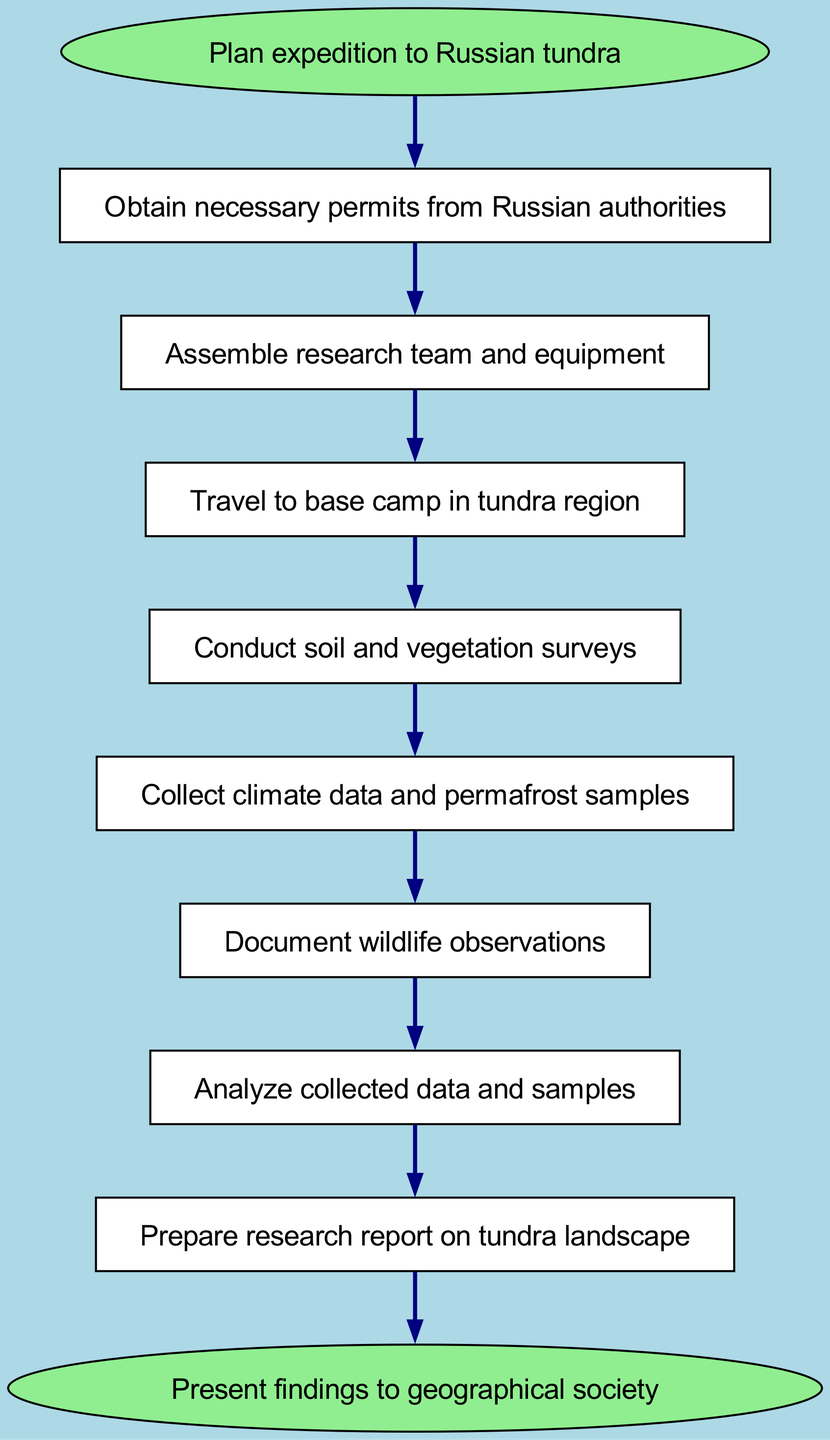What is the first step in the fieldwork process? The first step in the diagram is to "Plan expedition to Russian tundra," which is represented as the starting node.
Answer: Plan expedition to Russian tundra How many total nodes are present in the diagram? To find the total number of nodes, we count each distinct element represented, which includes the start and end nodes as well as the intermediate steps. There are 9 nodes in total.
Answer: 9 What step follows after assembling the research team and equipment? In the flow of the process, after "Assemble research team and equipment," the next step is "Travel to base camp in tundra region." This indicates the chronological order of activities.
Answer: Travel to base camp in tundra region What type of data is collected after conducting soil and vegetation surveys? The next action after conducting soil and vegetation surveys is to "Collect climate data and permafrost samples." This step follows directly from soil and vegetation surveys according to the diagram.
Answer: Collect climate data and permafrost samples What is the final action indicated in the fieldwork process? Looking at the end of the flowchart, the final action specified is "Present findings to geographical society," marking the conclusion of the fieldwork process.
Answer: Present findings to geographical society After documenting wildlife observations, what is the next step? Following the step of "Document wildlife observations," the subsequent action is "Analyze collected data and samples." This means that wildlife observation leads to data analysis.
Answer: Analyze collected data and samples Which step comes immediately before preparing the research report on the tundra landscape? The step that comes just before "Prepare research report on tundra landscape" is "Analyze collected data and samples." This indicates that data analysis is a prerequisite to reporting.
Answer: Analyze collected data and samples What is the first action that needs to be taken after planning the expedition? According to the flowchart, the first action after planning the expedition is to "Obtain necessary permits from Russian authorities." This is essential before proceeding to any fieldwork activities.
Answer: Obtain necessary permits from Russian authorities 